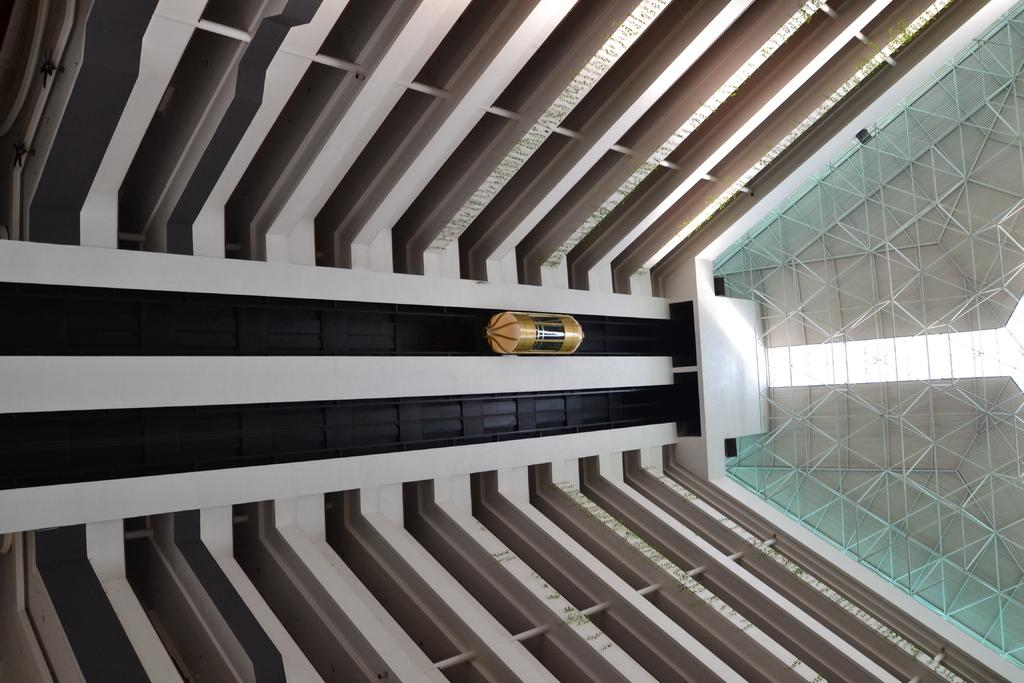What type of structure is depicted in the image? The image shows an inner view of a building. What can be seen in the middle of the image? There is a lift present in the middle of the image. What type of button can be seen on the frame of the window in the image? There is no window or button present in the image; it shows an inner view of a building with a lift in the middle. 